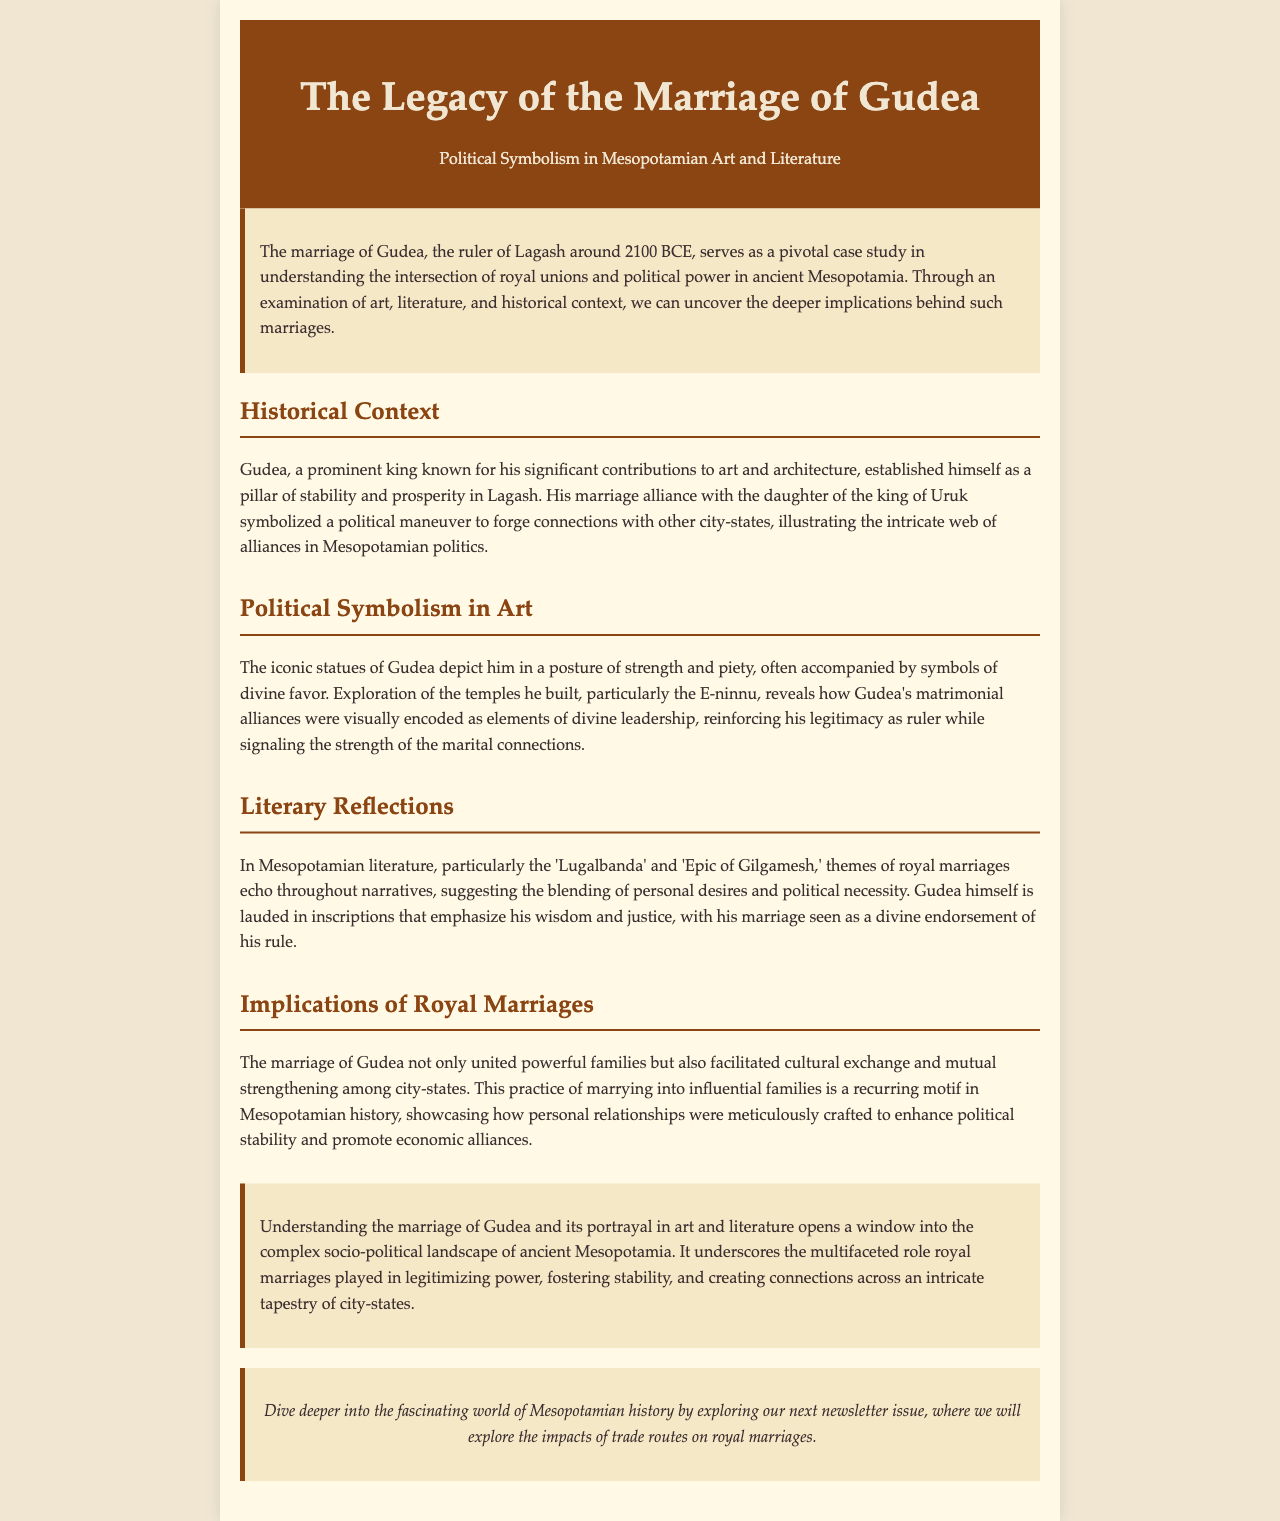What is the title of the newsletter? The title is prominently displayed at the top of the document.
Answer: The Legacy of the Marriage of Gudea Who was Gudea? The document explains who Gudea is in the introduction and historical context sections.
Answer: The ruler of Lagash What year did Gudea rule? The document specifies the approximate period during which Gudea ruled.
Answer: Around 2100 BCE What city-state did Gudea marry into? The document discusses Gudea's marriage and the political implications thereof.
Answer: Uruk What is the name of the temple built by Gudea? The document mentions this temple in the section discussing political symbolism in art.
Answer: E-ninnu What themes are present in Mesopotamian literature according to the newsletter? The document references specific themes that reflect royal marriages within Mesopotamian literature.
Answer: Royal marriages What role did Gudea's marriage play in politics? This question is elaborated in the implications of royal marriages section, discussing its significance.
Answer: Political stability What aspect of Gudea is emphasized in inscriptions? The document highlights specific qualities attributed to Gudea in the literary reflections.
Answer: Wisdom and justice What is the next newsletter issue topic? The document provides a teaser for the next issue at the end.
Answer: Trade routes on royal marriages 